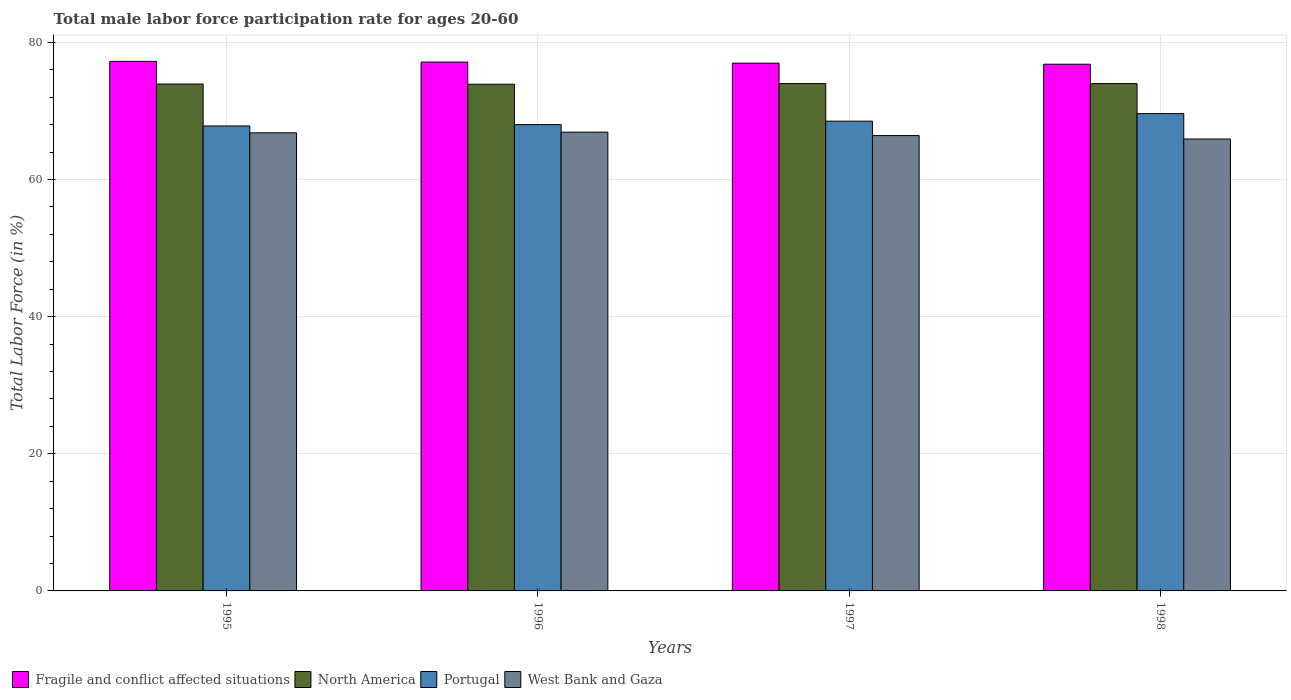How many different coloured bars are there?
Give a very brief answer. 4. How many groups of bars are there?
Keep it short and to the point. 4. Are the number of bars on each tick of the X-axis equal?
Make the answer very short. Yes. How many bars are there on the 4th tick from the right?
Offer a terse response. 4. What is the male labor force participation rate in West Bank and Gaza in 1998?
Keep it short and to the point. 65.9. Across all years, what is the maximum male labor force participation rate in Portugal?
Offer a terse response. 69.6. Across all years, what is the minimum male labor force participation rate in West Bank and Gaza?
Make the answer very short. 65.9. What is the total male labor force participation rate in North America in the graph?
Your answer should be very brief. 295.76. What is the difference between the male labor force participation rate in Portugal in 1995 and that in 1997?
Make the answer very short. -0.7. What is the difference between the male labor force participation rate in Portugal in 1998 and the male labor force participation rate in Fragile and conflict affected situations in 1995?
Provide a succinct answer. -7.62. What is the average male labor force participation rate in West Bank and Gaza per year?
Give a very brief answer. 66.5. In the year 1996, what is the difference between the male labor force participation rate in North America and male labor force participation rate in Fragile and conflict affected situations?
Ensure brevity in your answer.  -3.23. What is the ratio of the male labor force participation rate in West Bank and Gaza in 1995 to that in 1997?
Give a very brief answer. 1.01. Is the male labor force participation rate in West Bank and Gaza in 1996 less than that in 1998?
Your answer should be compact. No. Is the difference between the male labor force participation rate in North America in 1996 and 1997 greater than the difference between the male labor force participation rate in Fragile and conflict affected situations in 1996 and 1997?
Provide a short and direct response. No. What is the difference between the highest and the second highest male labor force participation rate in Portugal?
Offer a very short reply. 1.1. What is the difference between the highest and the lowest male labor force participation rate in Fragile and conflict affected situations?
Keep it short and to the point. 0.42. In how many years, is the male labor force participation rate in West Bank and Gaza greater than the average male labor force participation rate in West Bank and Gaza taken over all years?
Your answer should be compact. 2. Is the sum of the male labor force participation rate in Portugal in 1996 and 1997 greater than the maximum male labor force participation rate in West Bank and Gaza across all years?
Offer a very short reply. Yes. What does the 4th bar from the right in 1995 represents?
Your answer should be compact. Fragile and conflict affected situations. How many bars are there?
Your response must be concise. 16. Are all the bars in the graph horizontal?
Offer a terse response. No. What is the difference between two consecutive major ticks on the Y-axis?
Offer a terse response. 20. Does the graph contain grids?
Your answer should be very brief. Yes. How many legend labels are there?
Provide a succinct answer. 4. How are the legend labels stacked?
Provide a succinct answer. Horizontal. What is the title of the graph?
Provide a succinct answer. Total male labor force participation rate for ages 20-60. What is the Total Labor Force (in %) in Fragile and conflict affected situations in 1995?
Make the answer very short. 77.22. What is the Total Labor Force (in %) in North America in 1995?
Keep it short and to the point. 73.92. What is the Total Labor Force (in %) in Portugal in 1995?
Keep it short and to the point. 67.8. What is the Total Labor Force (in %) of West Bank and Gaza in 1995?
Offer a very short reply. 66.8. What is the Total Labor Force (in %) in Fragile and conflict affected situations in 1996?
Your answer should be compact. 77.12. What is the Total Labor Force (in %) of North America in 1996?
Your response must be concise. 73.89. What is the Total Labor Force (in %) in West Bank and Gaza in 1996?
Offer a very short reply. 66.9. What is the Total Labor Force (in %) of Fragile and conflict affected situations in 1997?
Offer a terse response. 76.96. What is the Total Labor Force (in %) of North America in 1997?
Your answer should be very brief. 73.98. What is the Total Labor Force (in %) of Portugal in 1997?
Your answer should be compact. 68.5. What is the Total Labor Force (in %) of West Bank and Gaza in 1997?
Offer a terse response. 66.4. What is the Total Labor Force (in %) of Fragile and conflict affected situations in 1998?
Give a very brief answer. 76.81. What is the Total Labor Force (in %) of North America in 1998?
Keep it short and to the point. 73.98. What is the Total Labor Force (in %) in Portugal in 1998?
Ensure brevity in your answer.  69.6. What is the Total Labor Force (in %) in West Bank and Gaza in 1998?
Ensure brevity in your answer.  65.9. Across all years, what is the maximum Total Labor Force (in %) of Fragile and conflict affected situations?
Keep it short and to the point. 77.22. Across all years, what is the maximum Total Labor Force (in %) in North America?
Offer a terse response. 73.98. Across all years, what is the maximum Total Labor Force (in %) in Portugal?
Offer a very short reply. 69.6. Across all years, what is the maximum Total Labor Force (in %) of West Bank and Gaza?
Provide a short and direct response. 66.9. Across all years, what is the minimum Total Labor Force (in %) of Fragile and conflict affected situations?
Provide a short and direct response. 76.81. Across all years, what is the minimum Total Labor Force (in %) in North America?
Your response must be concise. 73.89. Across all years, what is the minimum Total Labor Force (in %) in Portugal?
Make the answer very short. 67.8. Across all years, what is the minimum Total Labor Force (in %) in West Bank and Gaza?
Provide a succinct answer. 65.9. What is the total Total Labor Force (in %) of Fragile and conflict affected situations in the graph?
Offer a very short reply. 308.11. What is the total Total Labor Force (in %) in North America in the graph?
Give a very brief answer. 295.76. What is the total Total Labor Force (in %) of Portugal in the graph?
Your response must be concise. 273.9. What is the total Total Labor Force (in %) of West Bank and Gaza in the graph?
Offer a terse response. 266. What is the difference between the Total Labor Force (in %) of Fragile and conflict affected situations in 1995 and that in 1996?
Offer a terse response. 0.1. What is the difference between the Total Labor Force (in %) of North America in 1995 and that in 1996?
Ensure brevity in your answer.  0.03. What is the difference between the Total Labor Force (in %) of Portugal in 1995 and that in 1996?
Your response must be concise. -0.2. What is the difference between the Total Labor Force (in %) of West Bank and Gaza in 1995 and that in 1996?
Ensure brevity in your answer.  -0.1. What is the difference between the Total Labor Force (in %) in Fragile and conflict affected situations in 1995 and that in 1997?
Keep it short and to the point. 0.26. What is the difference between the Total Labor Force (in %) in North America in 1995 and that in 1997?
Provide a succinct answer. -0.06. What is the difference between the Total Labor Force (in %) of Fragile and conflict affected situations in 1995 and that in 1998?
Ensure brevity in your answer.  0.42. What is the difference between the Total Labor Force (in %) in North America in 1995 and that in 1998?
Your response must be concise. -0.06. What is the difference between the Total Labor Force (in %) of West Bank and Gaza in 1995 and that in 1998?
Keep it short and to the point. 0.9. What is the difference between the Total Labor Force (in %) of Fragile and conflict affected situations in 1996 and that in 1997?
Provide a short and direct response. 0.16. What is the difference between the Total Labor Force (in %) of North America in 1996 and that in 1997?
Give a very brief answer. -0.09. What is the difference between the Total Labor Force (in %) of Fragile and conflict affected situations in 1996 and that in 1998?
Make the answer very short. 0.31. What is the difference between the Total Labor Force (in %) of North America in 1996 and that in 1998?
Keep it short and to the point. -0.09. What is the difference between the Total Labor Force (in %) of Portugal in 1996 and that in 1998?
Your answer should be very brief. -1.6. What is the difference between the Total Labor Force (in %) of West Bank and Gaza in 1996 and that in 1998?
Offer a very short reply. 1. What is the difference between the Total Labor Force (in %) in Fragile and conflict affected situations in 1997 and that in 1998?
Offer a very short reply. 0.15. What is the difference between the Total Labor Force (in %) of North America in 1997 and that in 1998?
Your response must be concise. -0. What is the difference between the Total Labor Force (in %) of Portugal in 1997 and that in 1998?
Give a very brief answer. -1.1. What is the difference between the Total Labor Force (in %) in Fragile and conflict affected situations in 1995 and the Total Labor Force (in %) in North America in 1996?
Your answer should be compact. 3.34. What is the difference between the Total Labor Force (in %) in Fragile and conflict affected situations in 1995 and the Total Labor Force (in %) in Portugal in 1996?
Keep it short and to the point. 9.22. What is the difference between the Total Labor Force (in %) of Fragile and conflict affected situations in 1995 and the Total Labor Force (in %) of West Bank and Gaza in 1996?
Your answer should be very brief. 10.32. What is the difference between the Total Labor Force (in %) in North America in 1995 and the Total Labor Force (in %) in Portugal in 1996?
Provide a short and direct response. 5.92. What is the difference between the Total Labor Force (in %) of North America in 1995 and the Total Labor Force (in %) of West Bank and Gaza in 1996?
Make the answer very short. 7.02. What is the difference between the Total Labor Force (in %) of Portugal in 1995 and the Total Labor Force (in %) of West Bank and Gaza in 1996?
Your answer should be very brief. 0.9. What is the difference between the Total Labor Force (in %) in Fragile and conflict affected situations in 1995 and the Total Labor Force (in %) in North America in 1997?
Ensure brevity in your answer.  3.25. What is the difference between the Total Labor Force (in %) in Fragile and conflict affected situations in 1995 and the Total Labor Force (in %) in Portugal in 1997?
Make the answer very short. 8.72. What is the difference between the Total Labor Force (in %) in Fragile and conflict affected situations in 1995 and the Total Labor Force (in %) in West Bank and Gaza in 1997?
Make the answer very short. 10.82. What is the difference between the Total Labor Force (in %) in North America in 1995 and the Total Labor Force (in %) in Portugal in 1997?
Your response must be concise. 5.42. What is the difference between the Total Labor Force (in %) in North America in 1995 and the Total Labor Force (in %) in West Bank and Gaza in 1997?
Provide a succinct answer. 7.52. What is the difference between the Total Labor Force (in %) in Fragile and conflict affected situations in 1995 and the Total Labor Force (in %) in North America in 1998?
Offer a very short reply. 3.25. What is the difference between the Total Labor Force (in %) of Fragile and conflict affected situations in 1995 and the Total Labor Force (in %) of Portugal in 1998?
Provide a short and direct response. 7.62. What is the difference between the Total Labor Force (in %) in Fragile and conflict affected situations in 1995 and the Total Labor Force (in %) in West Bank and Gaza in 1998?
Your answer should be compact. 11.32. What is the difference between the Total Labor Force (in %) in North America in 1995 and the Total Labor Force (in %) in Portugal in 1998?
Offer a terse response. 4.32. What is the difference between the Total Labor Force (in %) in North America in 1995 and the Total Labor Force (in %) in West Bank and Gaza in 1998?
Provide a succinct answer. 8.02. What is the difference between the Total Labor Force (in %) of Portugal in 1995 and the Total Labor Force (in %) of West Bank and Gaza in 1998?
Give a very brief answer. 1.9. What is the difference between the Total Labor Force (in %) of Fragile and conflict affected situations in 1996 and the Total Labor Force (in %) of North America in 1997?
Your answer should be very brief. 3.14. What is the difference between the Total Labor Force (in %) of Fragile and conflict affected situations in 1996 and the Total Labor Force (in %) of Portugal in 1997?
Your answer should be compact. 8.62. What is the difference between the Total Labor Force (in %) of Fragile and conflict affected situations in 1996 and the Total Labor Force (in %) of West Bank and Gaza in 1997?
Your response must be concise. 10.72. What is the difference between the Total Labor Force (in %) of North America in 1996 and the Total Labor Force (in %) of Portugal in 1997?
Provide a short and direct response. 5.39. What is the difference between the Total Labor Force (in %) of North America in 1996 and the Total Labor Force (in %) of West Bank and Gaza in 1997?
Offer a very short reply. 7.49. What is the difference between the Total Labor Force (in %) in Portugal in 1996 and the Total Labor Force (in %) in West Bank and Gaza in 1997?
Make the answer very short. 1.6. What is the difference between the Total Labor Force (in %) of Fragile and conflict affected situations in 1996 and the Total Labor Force (in %) of North America in 1998?
Your answer should be very brief. 3.14. What is the difference between the Total Labor Force (in %) of Fragile and conflict affected situations in 1996 and the Total Labor Force (in %) of Portugal in 1998?
Keep it short and to the point. 7.52. What is the difference between the Total Labor Force (in %) in Fragile and conflict affected situations in 1996 and the Total Labor Force (in %) in West Bank and Gaza in 1998?
Offer a terse response. 11.22. What is the difference between the Total Labor Force (in %) of North America in 1996 and the Total Labor Force (in %) of Portugal in 1998?
Your response must be concise. 4.29. What is the difference between the Total Labor Force (in %) in North America in 1996 and the Total Labor Force (in %) in West Bank and Gaza in 1998?
Offer a terse response. 7.99. What is the difference between the Total Labor Force (in %) in Portugal in 1996 and the Total Labor Force (in %) in West Bank and Gaza in 1998?
Provide a short and direct response. 2.1. What is the difference between the Total Labor Force (in %) of Fragile and conflict affected situations in 1997 and the Total Labor Force (in %) of North America in 1998?
Your response must be concise. 2.98. What is the difference between the Total Labor Force (in %) in Fragile and conflict affected situations in 1997 and the Total Labor Force (in %) in Portugal in 1998?
Ensure brevity in your answer.  7.36. What is the difference between the Total Labor Force (in %) in Fragile and conflict affected situations in 1997 and the Total Labor Force (in %) in West Bank and Gaza in 1998?
Your answer should be compact. 11.06. What is the difference between the Total Labor Force (in %) in North America in 1997 and the Total Labor Force (in %) in Portugal in 1998?
Give a very brief answer. 4.38. What is the difference between the Total Labor Force (in %) of North America in 1997 and the Total Labor Force (in %) of West Bank and Gaza in 1998?
Give a very brief answer. 8.08. What is the average Total Labor Force (in %) of Fragile and conflict affected situations per year?
Your answer should be compact. 77.03. What is the average Total Labor Force (in %) of North America per year?
Ensure brevity in your answer.  73.94. What is the average Total Labor Force (in %) in Portugal per year?
Your response must be concise. 68.47. What is the average Total Labor Force (in %) in West Bank and Gaza per year?
Make the answer very short. 66.5. In the year 1995, what is the difference between the Total Labor Force (in %) in Fragile and conflict affected situations and Total Labor Force (in %) in North America?
Offer a very short reply. 3.31. In the year 1995, what is the difference between the Total Labor Force (in %) in Fragile and conflict affected situations and Total Labor Force (in %) in Portugal?
Make the answer very short. 9.42. In the year 1995, what is the difference between the Total Labor Force (in %) in Fragile and conflict affected situations and Total Labor Force (in %) in West Bank and Gaza?
Give a very brief answer. 10.42. In the year 1995, what is the difference between the Total Labor Force (in %) of North America and Total Labor Force (in %) of Portugal?
Provide a short and direct response. 6.12. In the year 1995, what is the difference between the Total Labor Force (in %) in North America and Total Labor Force (in %) in West Bank and Gaza?
Provide a short and direct response. 7.12. In the year 1995, what is the difference between the Total Labor Force (in %) of Portugal and Total Labor Force (in %) of West Bank and Gaza?
Your answer should be compact. 1. In the year 1996, what is the difference between the Total Labor Force (in %) of Fragile and conflict affected situations and Total Labor Force (in %) of North America?
Your answer should be very brief. 3.23. In the year 1996, what is the difference between the Total Labor Force (in %) in Fragile and conflict affected situations and Total Labor Force (in %) in Portugal?
Your answer should be compact. 9.12. In the year 1996, what is the difference between the Total Labor Force (in %) of Fragile and conflict affected situations and Total Labor Force (in %) of West Bank and Gaza?
Offer a very short reply. 10.22. In the year 1996, what is the difference between the Total Labor Force (in %) of North America and Total Labor Force (in %) of Portugal?
Offer a very short reply. 5.89. In the year 1996, what is the difference between the Total Labor Force (in %) of North America and Total Labor Force (in %) of West Bank and Gaza?
Offer a terse response. 6.99. In the year 1996, what is the difference between the Total Labor Force (in %) in Portugal and Total Labor Force (in %) in West Bank and Gaza?
Your response must be concise. 1.1. In the year 1997, what is the difference between the Total Labor Force (in %) in Fragile and conflict affected situations and Total Labor Force (in %) in North America?
Provide a succinct answer. 2.98. In the year 1997, what is the difference between the Total Labor Force (in %) of Fragile and conflict affected situations and Total Labor Force (in %) of Portugal?
Your response must be concise. 8.46. In the year 1997, what is the difference between the Total Labor Force (in %) in Fragile and conflict affected situations and Total Labor Force (in %) in West Bank and Gaza?
Keep it short and to the point. 10.56. In the year 1997, what is the difference between the Total Labor Force (in %) of North America and Total Labor Force (in %) of Portugal?
Offer a very short reply. 5.48. In the year 1997, what is the difference between the Total Labor Force (in %) of North America and Total Labor Force (in %) of West Bank and Gaza?
Offer a terse response. 7.58. In the year 1997, what is the difference between the Total Labor Force (in %) in Portugal and Total Labor Force (in %) in West Bank and Gaza?
Make the answer very short. 2.1. In the year 1998, what is the difference between the Total Labor Force (in %) in Fragile and conflict affected situations and Total Labor Force (in %) in North America?
Your answer should be very brief. 2.83. In the year 1998, what is the difference between the Total Labor Force (in %) in Fragile and conflict affected situations and Total Labor Force (in %) in Portugal?
Give a very brief answer. 7.21. In the year 1998, what is the difference between the Total Labor Force (in %) of Fragile and conflict affected situations and Total Labor Force (in %) of West Bank and Gaza?
Offer a terse response. 10.91. In the year 1998, what is the difference between the Total Labor Force (in %) in North America and Total Labor Force (in %) in Portugal?
Give a very brief answer. 4.38. In the year 1998, what is the difference between the Total Labor Force (in %) in North America and Total Labor Force (in %) in West Bank and Gaza?
Make the answer very short. 8.08. In the year 1998, what is the difference between the Total Labor Force (in %) of Portugal and Total Labor Force (in %) of West Bank and Gaza?
Keep it short and to the point. 3.7. What is the ratio of the Total Labor Force (in %) of North America in 1995 to that in 1996?
Make the answer very short. 1. What is the ratio of the Total Labor Force (in %) in Portugal in 1995 to that in 1996?
Keep it short and to the point. 1. What is the ratio of the Total Labor Force (in %) of West Bank and Gaza in 1995 to that in 1996?
Offer a terse response. 1. What is the ratio of the Total Labor Force (in %) of North America in 1995 to that in 1997?
Provide a succinct answer. 1. What is the ratio of the Total Labor Force (in %) of Fragile and conflict affected situations in 1995 to that in 1998?
Keep it short and to the point. 1.01. What is the ratio of the Total Labor Force (in %) of Portugal in 1995 to that in 1998?
Offer a terse response. 0.97. What is the ratio of the Total Labor Force (in %) in West Bank and Gaza in 1995 to that in 1998?
Give a very brief answer. 1.01. What is the ratio of the Total Labor Force (in %) of Portugal in 1996 to that in 1997?
Offer a very short reply. 0.99. What is the ratio of the Total Labor Force (in %) of West Bank and Gaza in 1996 to that in 1997?
Your answer should be compact. 1.01. What is the ratio of the Total Labor Force (in %) of Fragile and conflict affected situations in 1996 to that in 1998?
Provide a short and direct response. 1. What is the ratio of the Total Labor Force (in %) of Portugal in 1996 to that in 1998?
Provide a short and direct response. 0.98. What is the ratio of the Total Labor Force (in %) in West Bank and Gaza in 1996 to that in 1998?
Your answer should be compact. 1.02. What is the ratio of the Total Labor Force (in %) in North America in 1997 to that in 1998?
Your answer should be very brief. 1. What is the ratio of the Total Labor Force (in %) of Portugal in 1997 to that in 1998?
Your response must be concise. 0.98. What is the ratio of the Total Labor Force (in %) in West Bank and Gaza in 1997 to that in 1998?
Ensure brevity in your answer.  1.01. What is the difference between the highest and the second highest Total Labor Force (in %) of Fragile and conflict affected situations?
Ensure brevity in your answer.  0.1. What is the difference between the highest and the second highest Total Labor Force (in %) in Portugal?
Provide a short and direct response. 1.1. What is the difference between the highest and the second highest Total Labor Force (in %) of West Bank and Gaza?
Provide a short and direct response. 0.1. What is the difference between the highest and the lowest Total Labor Force (in %) in Fragile and conflict affected situations?
Your response must be concise. 0.42. What is the difference between the highest and the lowest Total Labor Force (in %) of North America?
Provide a succinct answer. 0.09. What is the difference between the highest and the lowest Total Labor Force (in %) of Portugal?
Ensure brevity in your answer.  1.8. What is the difference between the highest and the lowest Total Labor Force (in %) in West Bank and Gaza?
Give a very brief answer. 1. 